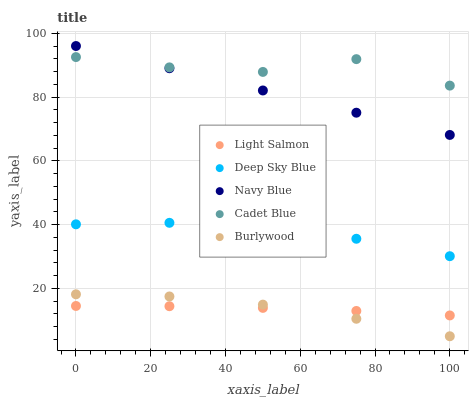Does Light Salmon have the minimum area under the curve?
Answer yes or no. Yes. Does Cadet Blue have the maximum area under the curve?
Answer yes or no. Yes. Does Navy Blue have the minimum area under the curve?
Answer yes or no. No. Does Navy Blue have the maximum area under the curve?
Answer yes or no. No. Is Navy Blue the smoothest?
Answer yes or no. Yes. Is Cadet Blue the roughest?
Answer yes or no. Yes. Is Light Salmon the smoothest?
Answer yes or no. No. Is Light Salmon the roughest?
Answer yes or no. No. Does Burlywood have the lowest value?
Answer yes or no. Yes. Does Navy Blue have the lowest value?
Answer yes or no. No. Does Navy Blue have the highest value?
Answer yes or no. Yes. Does Light Salmon have the highest value?
Answer yes or no. No. Is Light Salmon less than Cadet Blue?
Answer yes or no. Yes. Is Navy Blue greater than Light Salmon?
Answer yes or no. Yes. Does Light Salmon intersect Burlywood?
Answer yes or no. Yes. Is Light Salmon less than Burlywood?
Answer yes or no. No. Is Light Salmon greater than Burlywood?
Answer yes or no. No. Does Light Salmon intersect Cadet Blue?
Answer yes or no. No. 